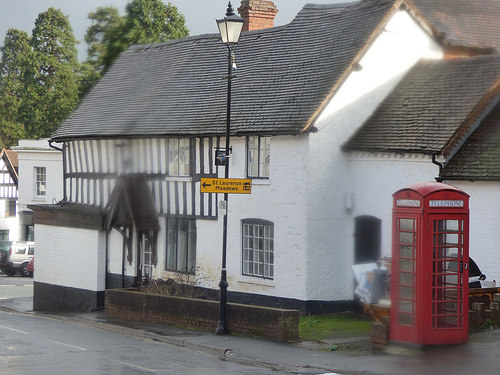<image>
Is there a phone booth to the left of the lamp post? No. The phone booth is not to the left of the lamp post. From this viewpoint, they have a different horizontal relationship. 